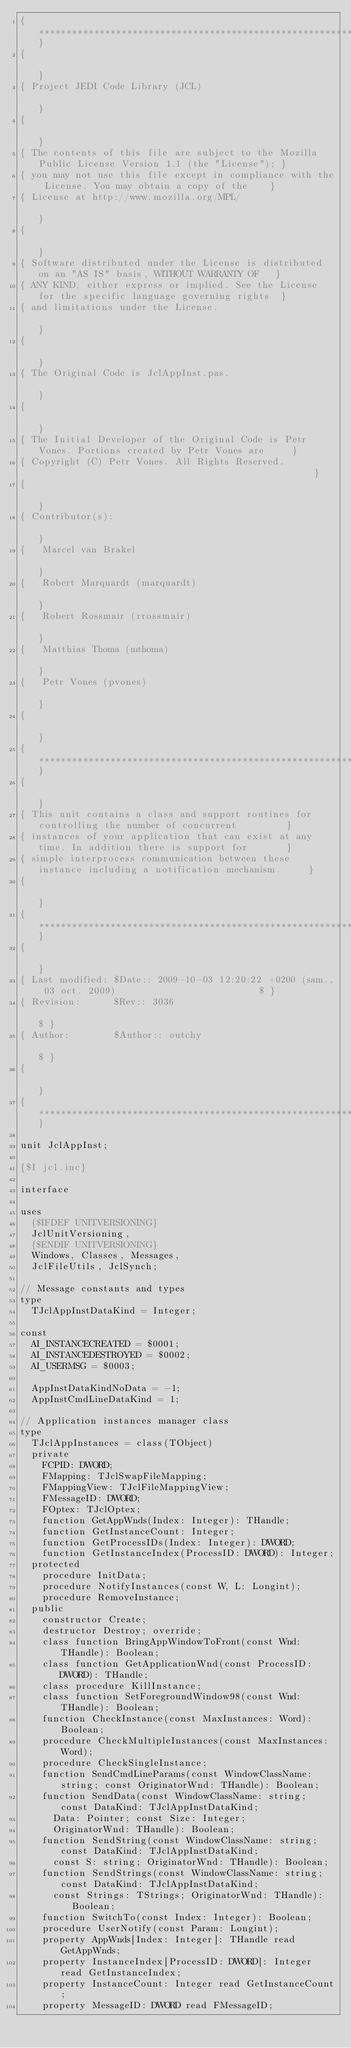Convert code to text. <code><loc_0><loc_0><loc_500><loc_500><_Pascal_>{**************************************************************************************************}
{                                                                                                  }
{ Project JEDI Code Library (JCL)                                                                  }
{                                                                                                  }
{ The contents of this file are subject to the Mozilla Public License Version 1.1 (the "License"); }
{ you may not use this file except in compliance with the License. You may obtain a copy of the    }
{ License at http://www.mozilla.org/MPL/                                                           }
{                                                                                                  }
{ Software distributed under the License is distributed on an "AS IS" basis, WITHOUT WARRANTY OF   }
{ ANY KIND, either express or implied. See the License for the specific language governing rights  }
{ and limitations under the License.                                                               }
{                                                                                                  }
{ The Original Code is JclAppInst.pas.                                                             }
{                                                                                                  }
{ The Initial Developer of the Original Code is Petr Vones. Portions created by Petr Vones are     }
{ Copyright (C) Petr Vones. All Rights Reserved.                                                   }
{                                                                                                  }
{ Contributor(s):                                                                                  }
{   Marcel van Brakel                                                                              }
{   Robert Marquardt (marquardt)                                                                   }
{   Robert Rossmair (rrossmair)                                                                    }
{   Matthias Thoma (mthoma)                                                                        }
{   Petr Vones (pvones)                                                                            }
{                                                                                                  }
{**************************************************************************************************}
{                                                                                                  }
{ This unit contains a class and support routines for controlling the number of concurrent         }
{ instances of your application that can exist at any time. In addition there is support for       }
{ simple interprocess communication between these instance including a notification mechanism.     }
{                                                                                                  }
{**************************************************************************************************}
{                                                                                                  }
{ Last modified: $Date:: 2009-10-03 12:20:22 +0200 (sam., 03 oct. 2009)                          $ }
{ Revision:      $Rev:: 3036                                                                     $ }
{ Author:        $Author:: outchy                                                                $ }
{                                                                                                  }
{**************************************************************************************************}

unit JclAppInst;

{$I jcl.inc}

interface

uses
  {$IFDEF UNITVERSIONING}
  JclUnitVersioning,
  {$ENDIF UNITVERSIONING}
  Windows, Classes, Messages,
  JclFileUtils, JclSynch;

// Message constants and types
type
  TJclAppInstDataKind = Integer;

const
  AI_INSTANCECREATED = $0001;
  AI_INSTANCEDESTROYED = $0002;
  AI_USERMSG = $0003;

  AppInstDataKindNoData = -1;
  AppInstCmdLineDataKind = 1;

// Application instances manager class
type
  TJclAppInstances = class(TObject)
  private
    FCPID: DWORD;
    FMapping: TJclSwapFileMapping;
    FMappingView: TJclFileMappingView;
    FMessageID: DWORD;
    FOptex: TJclOptex;
    function GetAppWnds(Index: Integer): THandle;
    function GetInstanceCount: Integer;
    function GetProcessIDs(Index: Integer): DWORD;
    function GetInstanceIndex(ProcessID: DWORD): Integer;
  protected
    procedure InitData;
    procedure NotifyInstances(const W, L: Longint);
    procedure RemoveInstance;
  public
    constructor Create;
    destructor Destroy; override;
    class function BringAppWindowToFront(const Wnd: THandle): Boolean;
    class function GetApplicationWnd(const ProcessID: DWORD): THandle;
    class procedure KillInstance;
    class function SetForegroundWindow98(const Wnd: THandle): Boolean;
    function CheckInstance(const MaxInstances: Word): Boolean;
    procedure CheckMultipleInstances(const MaxInstances: Word);
    procedure CheckSingleInstance;
    function SendCmdLineParams(const WindowClassName: string; const OriginatorWnd: THandle): Boolean;
    function SendData(const WindowClassName: string; const DataKind: TJclAppInstDataKind;
      Data: Pointer; const Size: Integer;
      OriginatorWnd: THandle): Boolean;
    function SendString(const WindowClassName: string; const DataKind: TJclAppInstDataKind;
      const S: string; OriginatorWnd: THandle): Boolean;
    function SendStrings(const WindowClassName: string; const DataKind: TJclAppInstDataKind;
      const Strings: TStrings; OriginatorWnd: THandle): Boolean;
    function SwitchTo(const Index: Integer): Boolean;
    procedure UserNotify(const Param: Longint);
    property AppWnds[Index: Integer]: THandle read GetAppWnds;
    property InstanceIndex[ProcessID: DWORD]: Integer read GetInstanceIndex;
    property InstanceCount: Integer read GetInstanceCount;
    property MessageID: DWORD read FMessageID;</code> 